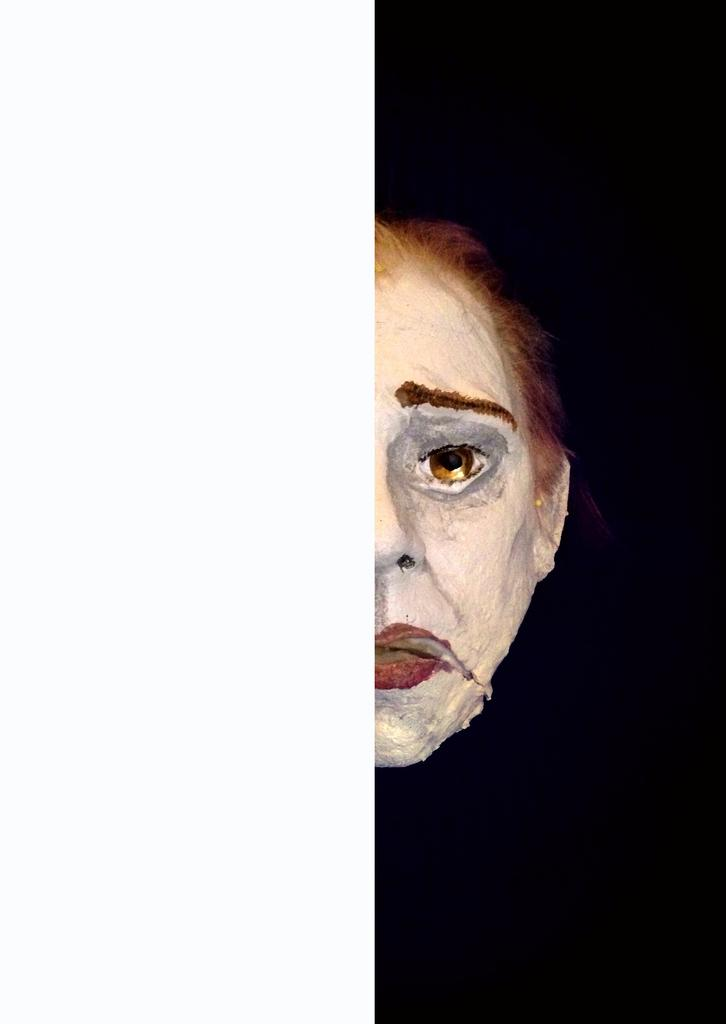What is the main subject of the image? There is a human face in the image. How many bridges can be seen crossing the river in the image? There is no river or bridge present in the image; it features a human face. What type of liquid is being consumed by the flock of birds in the image? There are no birds or liquid present in the image; it features a human face. 